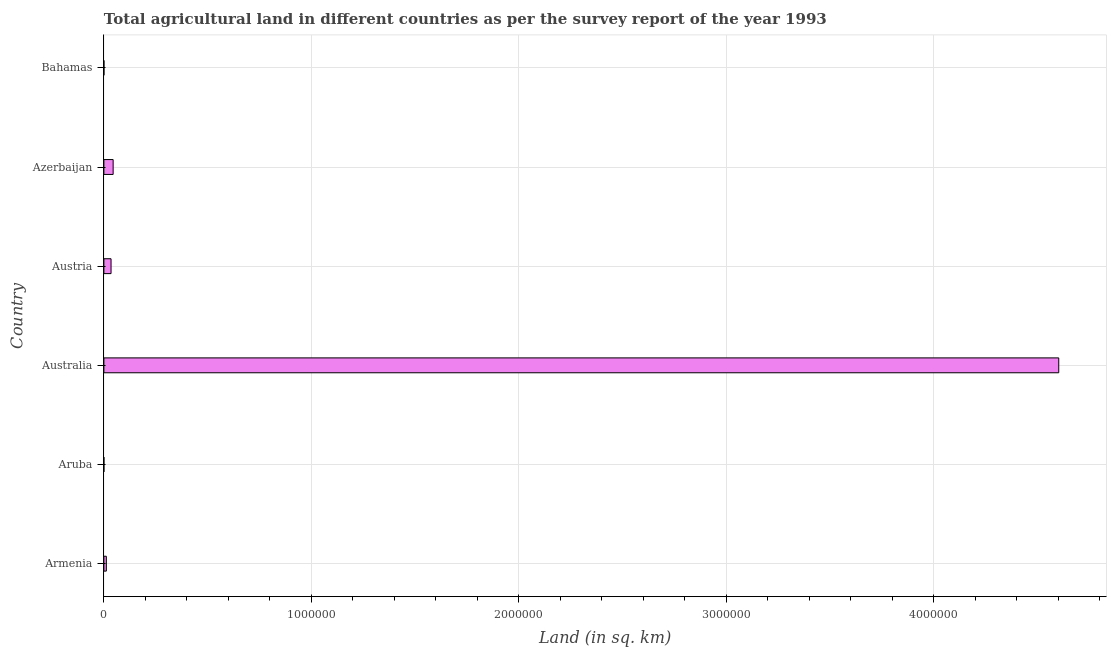Does the graph contain any zero values?
Offer a very short reply. No. What is the title of the graph?
Provide a short and direct response. Total agricultural land in different countries as per the survey report of the year 1993. What is the label or title of the X-axis?
Provide a short and direct response. Land (in sq. km). What is the label or title of the Y-axis?
Keep it short and to the point. Country. Across all countries, what is the maximum agricultural land?
Ensure brevity in your answer.  4.60e+06. Across all countries, what is the minimum agricultural land?
Give a very brief answer. 20. In which country was the agricultural land minimum?
Offer a terse response. Aruba. What is the sum of the agricultural land?
Make the answer very short. 4.69e+06. What is the difference between the agricultural land in Armenia and Australia?
Keep it short and to the point. -4.59e+06. What is the average agricultural land per country?
Provide a short and direct response. 7.82e+05. What is the median agricultural land?
Provide a succinct answer. 2.32e+04. What is the ratio of the agricultural land in Armenia to that in Austria?
Your answer should be compact. 0.34. Is the agricultural land in Aruba less than that in Austria?
Provide a succinct answer. Yes. What is the difference between the highest and the second highest agricultural land?
Make the answer very short. 4.56e+06. What is the difference between the highest and the lowest agricultural land?
Give a very brief answer. 4.60e+06. How many countries are there in the graph?
Keep it short and to the point. 6. What is the difference between two consecutive major ticks on the X-axis?
Keep it short and to the point. 1.00e+06. Are the values on the major ticks of X-axis written in scientific E-notation?
Your answer should be compact. No. What is the Land (in sq. km) of Armenia?
Make the answer very short. 1.18e+04. What is the Land (in sq. km) in Aruba?
Ensure brevity in your answer.  20. What is the Land (in sq. km) of Australia?
Provide a succinct answer. 4.60e+06. What is the Land (in sq. km) of Austria?
Your answer should be compact. 3.45e+04. What is the Land (in sq. km) in Azerbaijan?
Give a very brief answer. 4.46e+04. What is the Land (in sq. km) in Bahamas?
Provide a succinct answer. 120. What is the difference between the Land (in sq. km) in Armenia and Aruba?
Offer a terse response. 1.18e+04. What is the difference between the Land (in sq. km) in Armenia and Australia?
Your response must be concise. -4.59e+06. What is the difference between the Land (in sq. km) in Armenia and Austria?
Keep it short and to the point. -2.27e+04. What is the difference between the Land (in sq. km) in Armenia and Azerbaijan?
Keep it short and to the point. -3.28e+04. What is the difference between the Land (in sq. km) in Armenia and Bahamas?
Offer a terse response. 1.17e+04. What is the difference between the Land (in sq. km) in Aruba and Australia?
Give a very brief answer. -4.60e+06. What is the difference between the Land (in sq. km) in Aruba and Austria?
Make the answer very short. -3.45e+04. What is the difference between the Land (in sq. km) in Aruba and Azerbaijan?
Offer a terse response. -4.45e+04. What is the difference between the Land (in sq. km) in Aruba and Bahamas?
Your answer should be compact. -100. What is the difference between the Land (in sq. km) in Australia and Austria?
Offer a terse response. 4.57e+06. What is the difference between the Land (in sq. km) in Australia and Azerbaijan?
Offer a very short reply. 4.56e+06. What is the difference between the Land (in sq. km) in Australia and Bahamas?
Your answer should be compact. 4.60e+06. What is the difference between the Land (in sq. km) in Austria and Azerbaijan?
Your response must be concise. -1.00e+04. What is the difference between the Land (in sq. km) in Austria and Bahamas?
Ensure brevity in your answer.  3.44e+04. What is the difference between the Land (in sq. km) in Azerbaijan and Bahamas?
Provide a short and direct response. 4.44e+04. What is the ratio of the Land (in sq. km) in Armenia to that in Aruba?
Your answer should be very brief. 590.5. What is the ratio of the Land (in sq. km) in Armenia to that in Australia?
Provide a short and direct response. 0. What is the ratio of the Land (in sq. km) in Armenia to that in Austria?
Offer a terse response. 0.34. What is the ratio of the Land (in sq. km) in Armenia to that in Azerbaijan?
Offer a terse response. 0.27. What is the ratio of the Land (in sq. km) in Armenia to that in Bahamas?
Your answer should be very brief. 98.42. What is the ratio of the Land (in sq. km) in Aruba to that in Austria?
Your answer should be compact. 0. What is the ratio of the Land (in sq. km) in Aruba to that in Bahamas?
Offer a terse response. 0.17. What is the ratio of the Land (in sq. km) in Australia to that in Austria?
Offer a very short reply. 133.34. What is the ratio of the Land (in sq. km) in Australia to that in Azerbaijan?
Your answer should be compact. 103.28. What is the ratio of the Land (in sq. km) in Australia to that in Bahamas?
Your answer should be very brief. 3.84e+04. What is the ratio of the Land (in sq. km) in Austria to that in Azerbaijan?
Keep it short and to the point. 0.78. What is the ratio of the Land (in sq. km) in Austria to that in Bahamas?
Your answer should be compact. 287.67. What is the ratio of the Land (in sq. km) in Azerbaijan to that in Bahamas?
Keep it short and to the point. 371.38. 